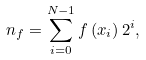<formula> <loc_0><loc_0><loc_500><loc_500>n _ { f } = \sum _ { i = 0 } ^ { N - 1 } f \left ( x _ { i } \right ) 2 ^ { i } ,</formula> 